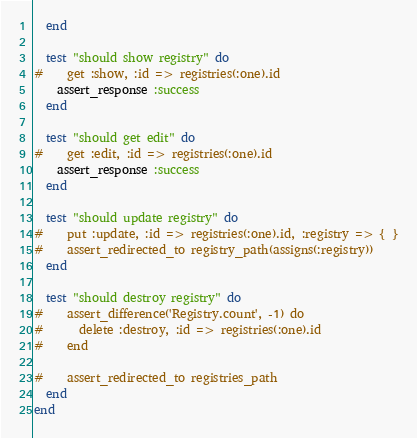Convert code to text. <code><loc_0><loc_0><loc_500><loc_500><_Ruby_>  end

  test "should show registry" do
#    get :show, :id => registries(:one).id
    assert_response :success
  end

  test "should get edit" do
#    get :edit, :id => registries(:one).id
    assert_response :success
  end

  test "should update registry" do
#    put :update, :id => registries(:one).id, :registry => { }
#    assert_redirected_to registry_path(assigns(:registry))
  end

  test "should destroy registry" do
#    assert_difference('Registry.count', -1) do
#      delete :destroy, :id => registries(:one).id
#    end

#    assert_redirected_to registries_path
  end
end
</code> 